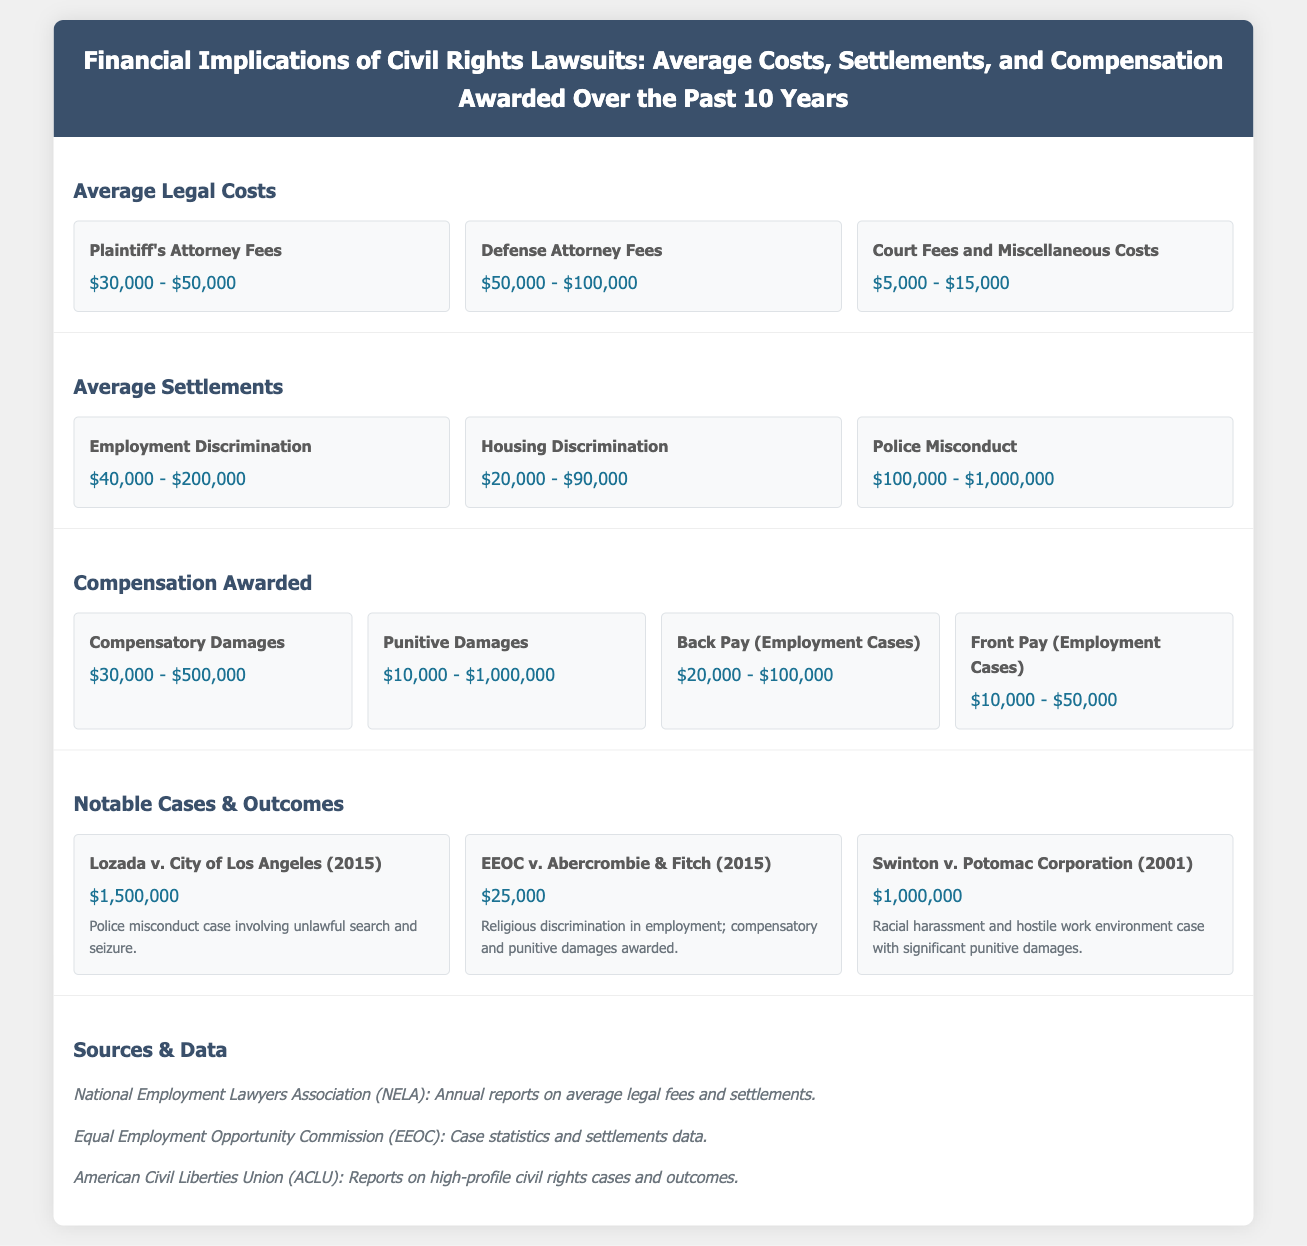What is the range of plaintiff's attorney fees? The document states that plaintiff's attorney fees range from $30,000 to $50,000.
Answer: $30,000 - $50,000 What is the average settlement amount for police misconduct cases? The document indicates that police misconduct settlements range from $100,000 to $1,000,000.
Answer: $100,000 - $1,000,000 What is the highest amount awarded in compensatory damages? The highest amount for compensatory damages listed in the document is $500,000.
Answer: $500,000 Which case involved religious discrimination? The document lists EEOC v. Abercrombie & Fitch as the case involving religious discrimination in employment.
Answer: EEOC v. Abercrombie & Fitch How much did Lozada v. City of Los Angeles settle for? The document states that Lozada v. City of Los Angeles settled for $1,500,000.
Answer: $1,500,000 What type of damages can reach up to $1,000,000? The document mentions that punitive damages can reach up to $1,000,000.
Answer: Punitive Damages Which category has the lowest average settlement range? The document shows that housing discrimination has the lowest average settlement range ($20,000 - $90,000).
Answer: Housing Discrimination How long have the data and statistics covered been gathered? The document explicitly states that the statistics cover the past 10 years.
Answer: 10 years 